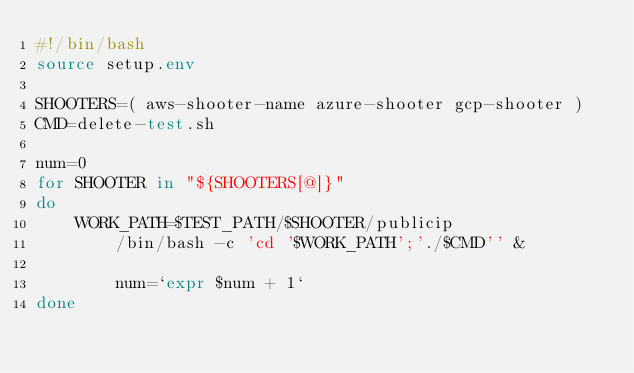<code> <loc_0><loc_0><loc_500><loc_500><_Bash_>#!/bin/bash
source setup.env

SHOOTERS=( aws-shooter-name azure-shooter gcp-shooter )
CMD=delete-test.sh

num=0
for SHOOTER in "${SHOOTERS[@]}"
do
	WORK_PATH=$TEST_PATH/$SHOOTER/publicip
        /bin/bash -c 'cd '$WORK_PATH';'./$CMD'' &

        num=`expr $num + 1`
done


</code> 